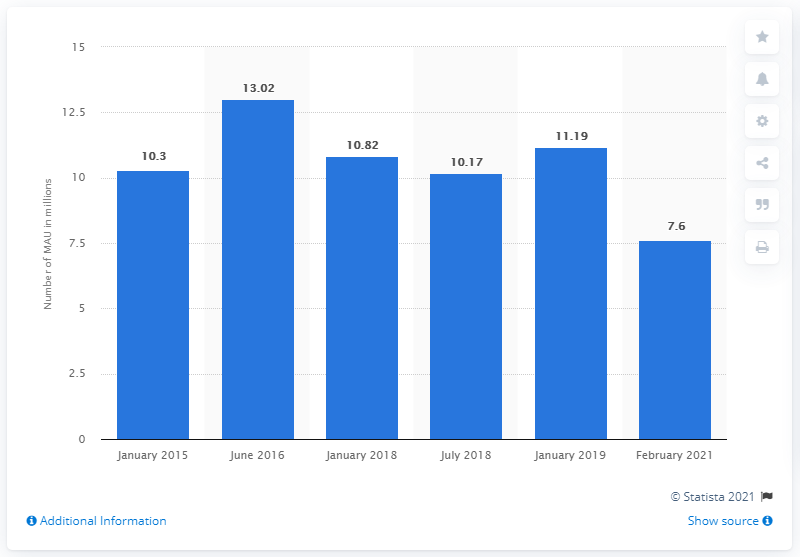Indicate a few pertinent items in this graphic. The peak of the Monthly Active Users (MAU) figure occurred in June 2016. 